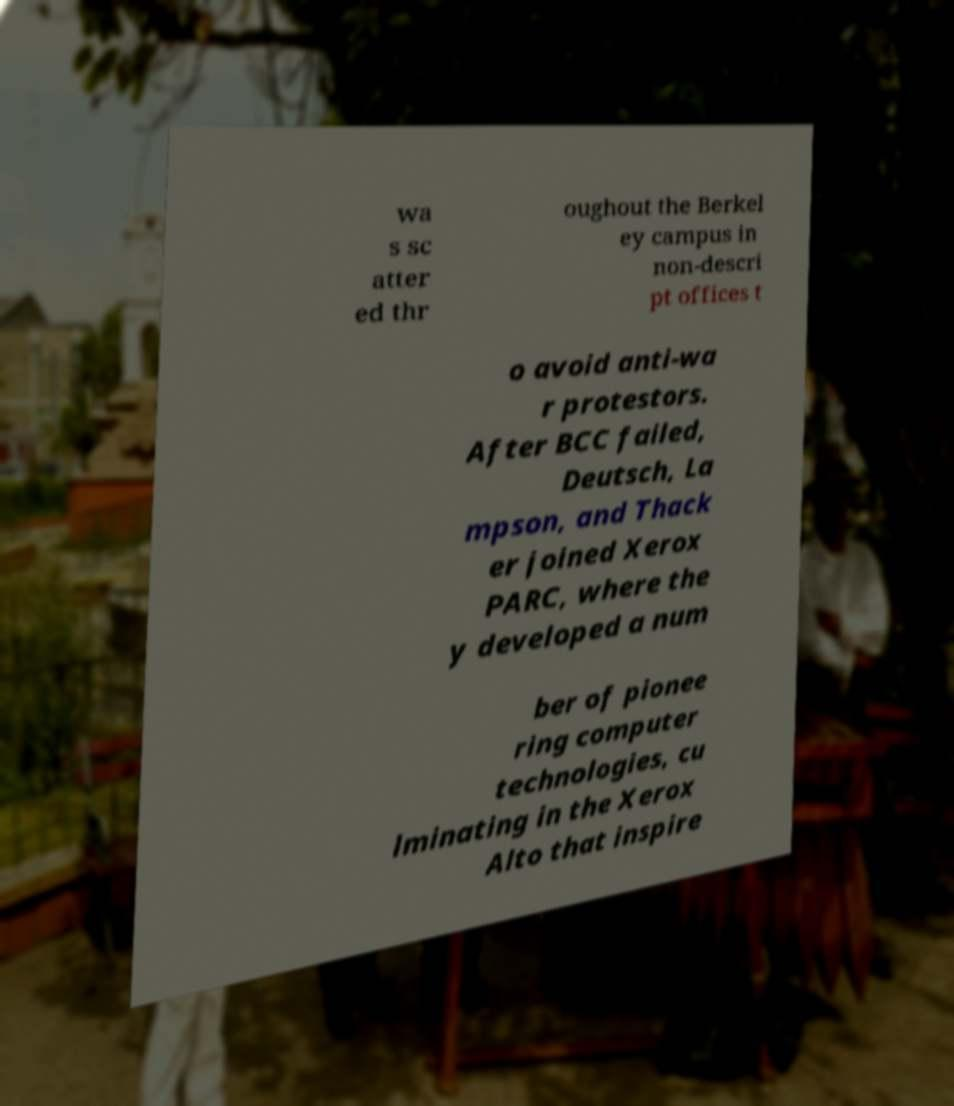Could you extract and type out the text from this image? wa s sc atter ed thr oughout the Berkel ey campus in non-descri pt offices t o avoid anti-wa r protestors. After BCC failed, Deutsch, La mpson, and Thack er joined Xerox PARC, where the y developed a num ber of pionee ring computer technologies, cu lminating in the Xerox Alto that inspire 